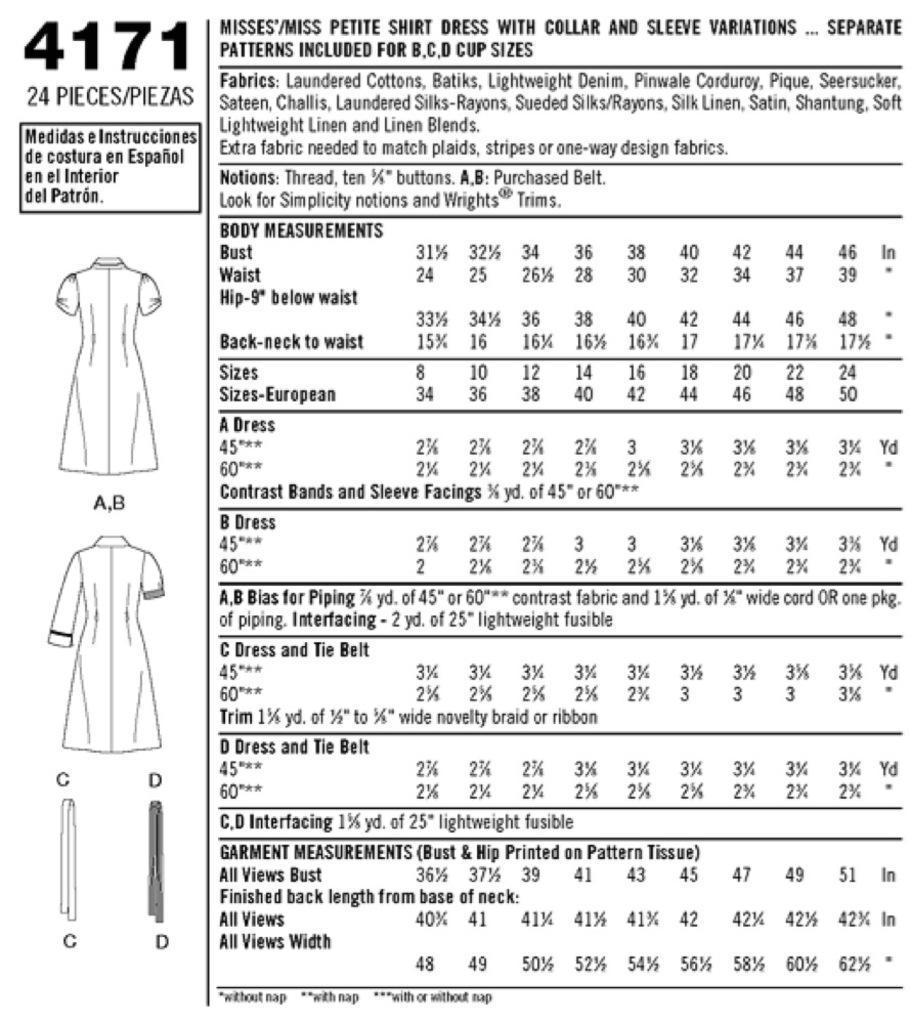Could you give a brief overview of what you see in this image? In this image we can see a chart of ladies dress there is some text written in words and numerical. 